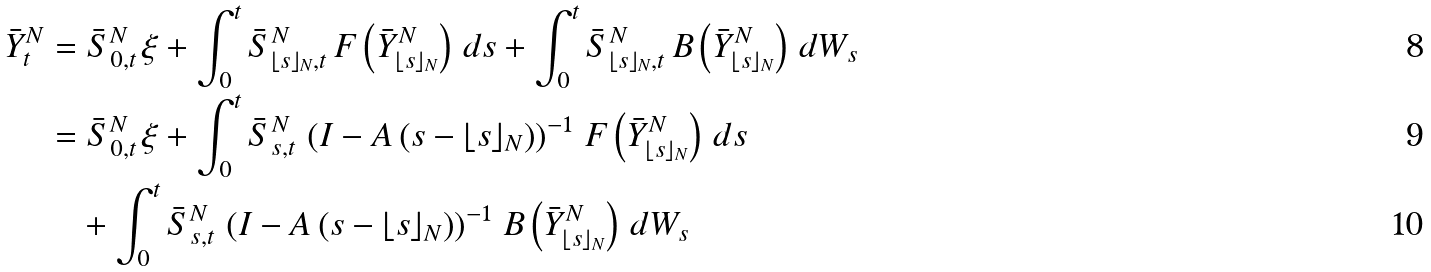<formula> <loc_0><loc_0><loc_500><loc_500>\bar { Y } ^ { N } _ { t } & = \bar { S } ^ { N } _ { 0 , t } \, \xi + \int _ { 0 } ^ { t } \bar { S } _ { \lfloor s \rfloor _ { N } , t } ^ { N } \, F \left ( \bar { Y } ^ { N } _ { \lfloor s \rfloor _ { N } } \right ) \, d s + \int _ { 0 } ^ { t } \bar { S } _ { \lfloor s \rfloor _ { N } , t } ^ { N } \, B \left ( \bar { Y } ^ { N } _ { \lfloor s \rfloor _ { N } } \right ) \, d W _ { s } \\ & = \bar { S } ^ { N } _ { 0 , t } \, \xi + \int _ { 0 } ^ { t } \bar { S } _ { s , t } ^ { N } \, \left ( I - A \left ( s - \lfloor s \rfloor _ { N } \right ) \right ) ^ { - 1 } \, F \left ( \bar { Y } ^ { N } _ { \lfloor s \rfloor _ { N } } \right ) \, d s \\ & \quad + \int _ { 0 } ^ { t } \bar { S } _ { s , t } ^ { N } \, \left ( I - A \left ( s - \lfloor s \rfloor _ { N } \right ) \right ) ^ { - 1 } \, B \left ( \bar { Y } ^ { N } _ { \lfloor s \rfloor _ { N } } \right ) \, d W _ { s }</formula> 